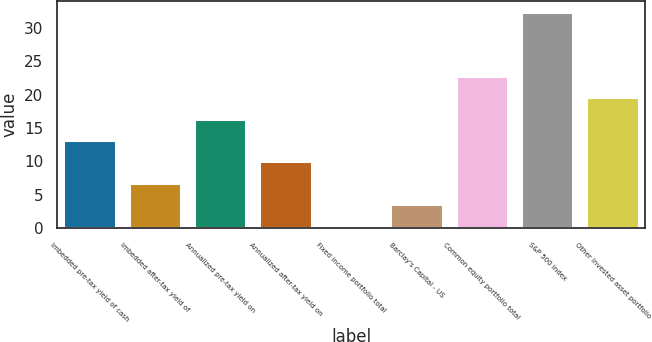Convert chart. <chart><loc_0><loc_0><loc_500><loc_500><bar_chart><fcel>Imbedded pre-tax yield of cash<fcel>Imbedded after-tax yield of<fcel>Annualized pre-tax yield on<fcel>Annualized after-tax yield on<fcel>Fixed income portfolio total<fcel>Barclay's Capital - US<fcel>Common equity portfolio total<fcel>S&P 500 index<fcel>Other invested asset portfolio<nl><fcel>13.2<fcel>6.8<fcel>16.4<fcel>10<fcel>0.4<fcel>3.6<fcel>22.8<fcel>32.4<fcel>19.6<nl></chart> 